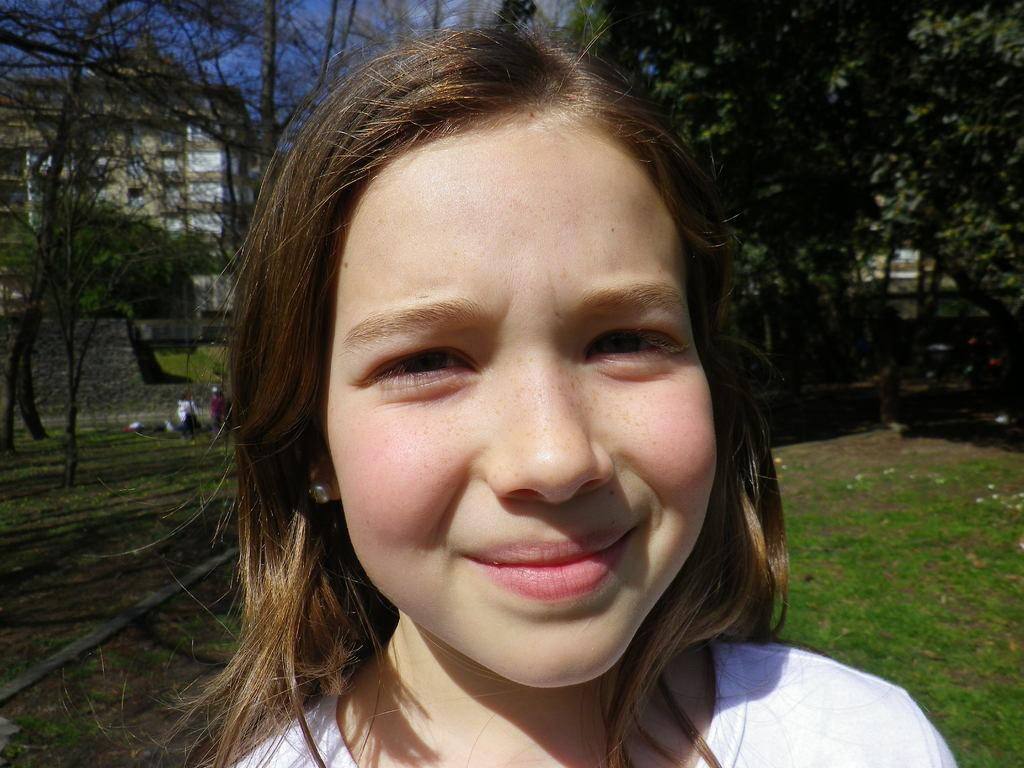Who is the main subject in the image? There is a girl in the image. What type of natural environment is visible in the image? There is grass in the image. What can be seen in the background of the image? There are trees, a building, a wall, and people in the background of the image. What is the weather like in the image? The sky is sunny in the image. What type of pies is the lawyer holding in the image? There is no lawyer or pies present in the image. 